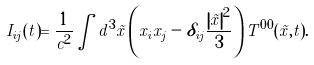<formula> <loc_0><loc_0><loc_500><loc_500>I _ { i j } ( t ) = \frac { 1 } { c ^ { 2 } } \int d ^ { 3 } \vec { x } \left ( x _ { i } x _ { j } - \delta _ { i j } \frac { \left | \vec { x } \right | ^ { 2 } } { 3 } \right ) T ^ { 0 0 } ( \vec { x } , t ) .</formula> 